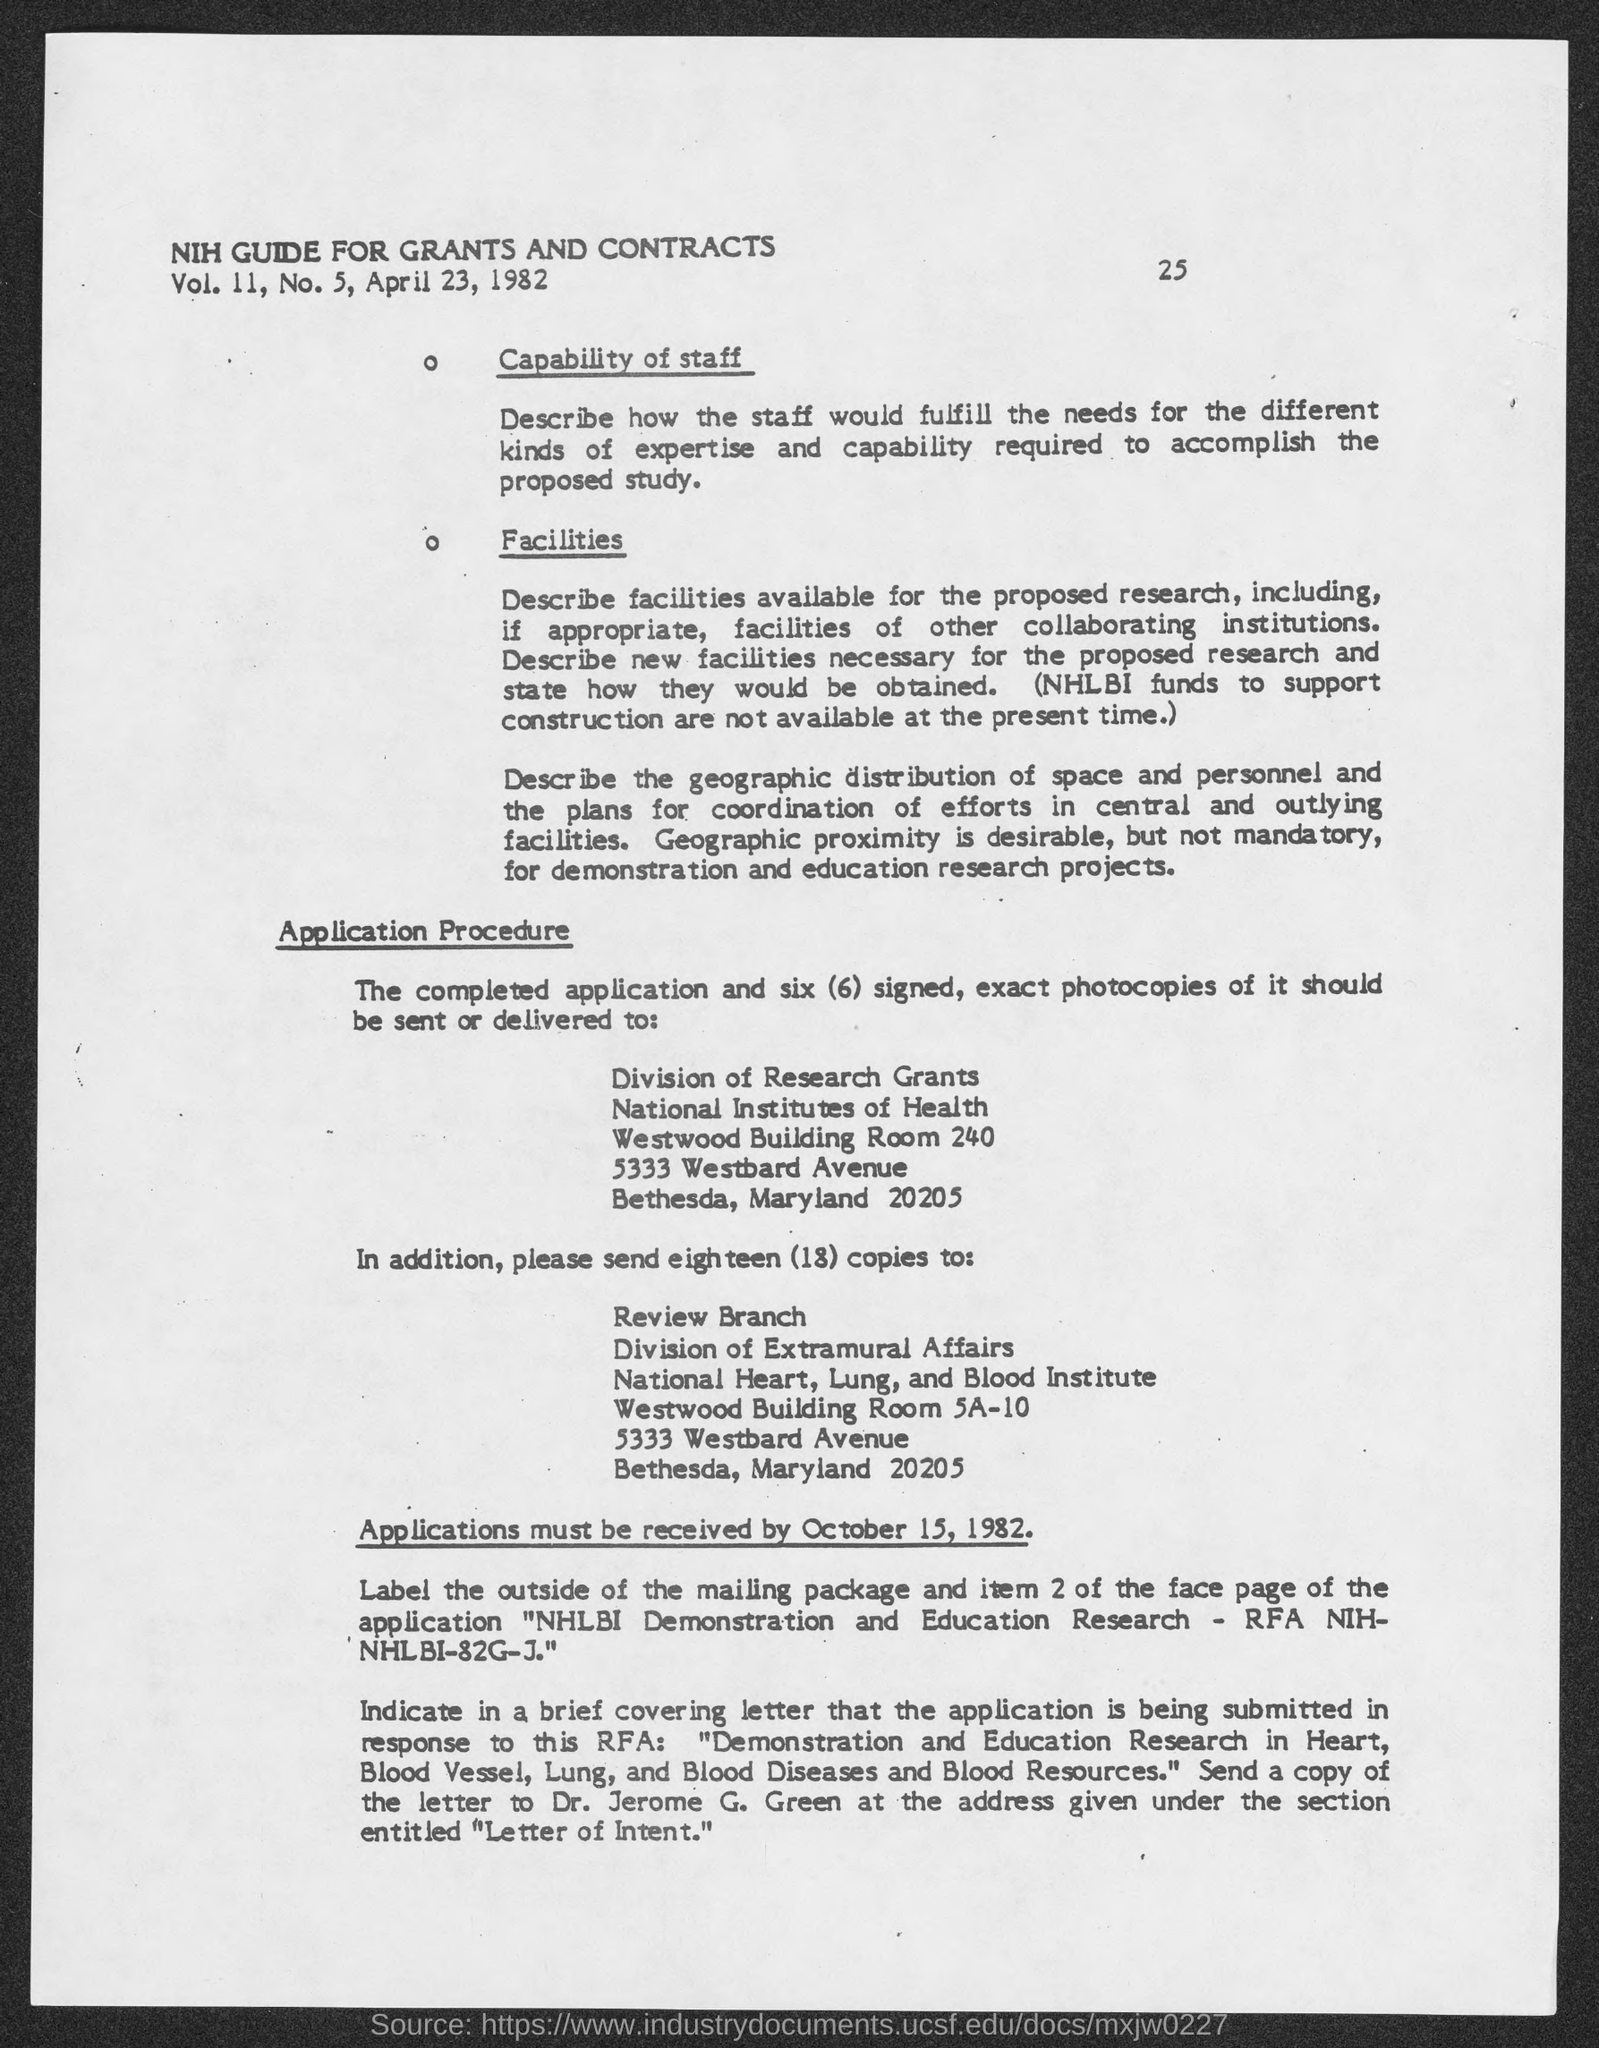What is the avenue address of national institutes of health ?
Offer a terse response. 5333 westbard avenue. What is the avenue address of national heart, lung and blood institute?
Provide a short and direct response. 5333 westbard avenue. By what date must applications must be received ?
Provide a succinct answer. October 15, 1982. What is the page number at top of the page?
Provide a succinct answer. 25. What is the vol. ii no.?
Make the answer very short. 5. 